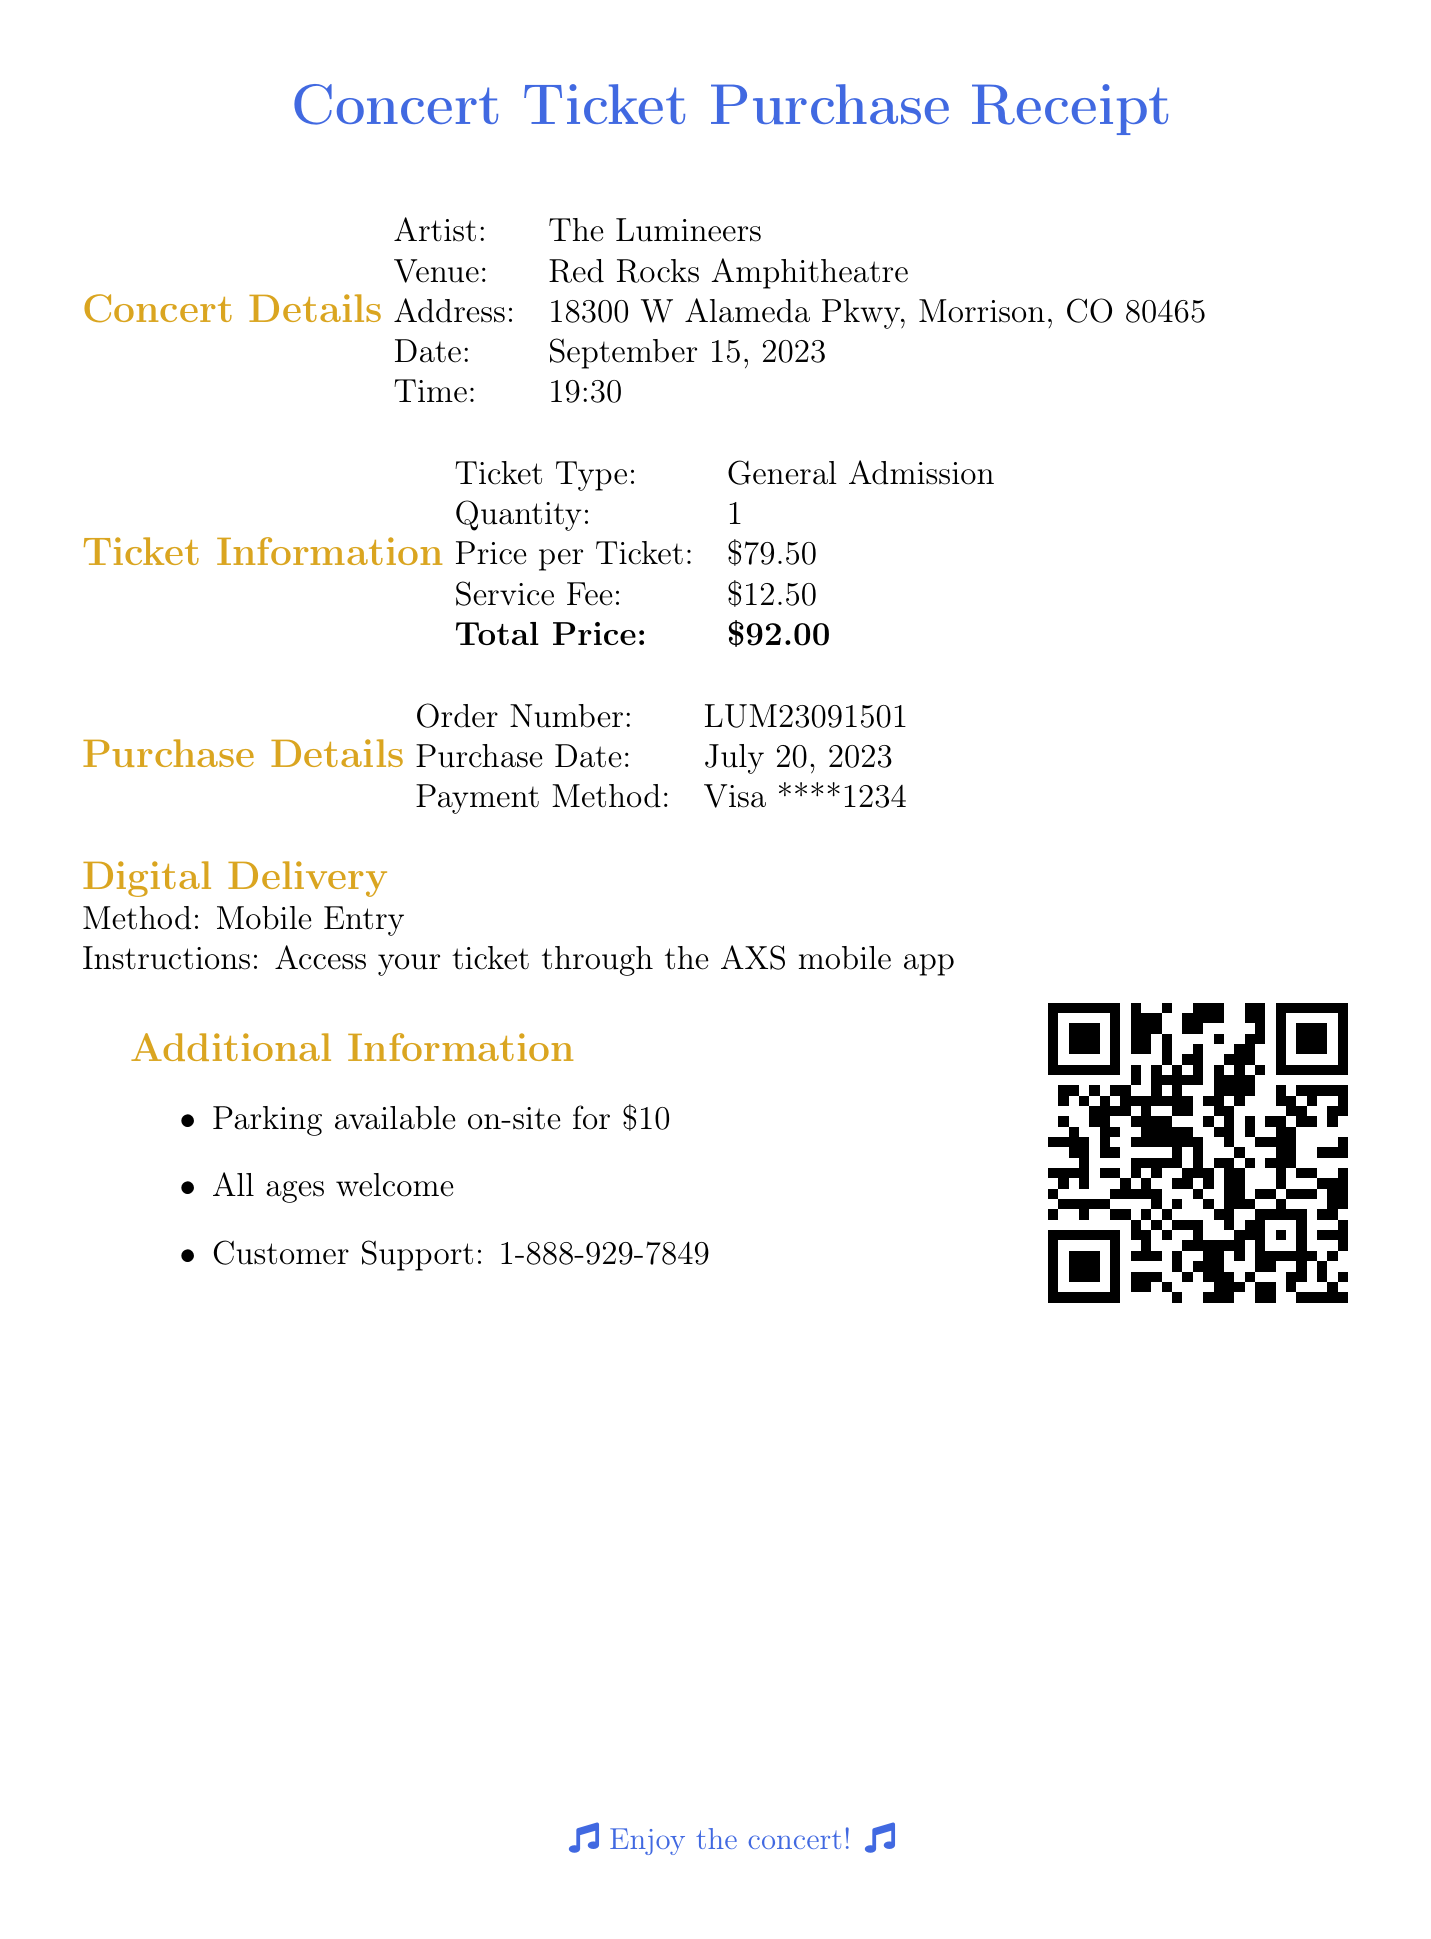What is the artist's name? The artist's name is explicitly stated in the concert details section of the document.
Answer: The Lumineers What is the venue for the concert? The venue is listed in the concert details section of the document.
Answer: Red Rocks Amphitheatre What date is the concert scheduled for? The concert date is provided in the concert details section.
Answer: September 15, 2023 What is the total price of the ticket? The total price is detailed in the ticket information section and includes all fees.
Answer: $92.00 What is the order number for this purchase? The order number is specified in the purchase details section and serves as a unique identifier.
Answer: LUM23091501 What payment method was used for this purchase? The payment method is found in the purchase details, indicating how the transaction was processed.
Answer: Visa ****1234 How much is the service fee for the ticket? The service fee is clearly stated in the ticket information section of the document.
Answer: $12.50 What delivery method will be used for the ticket? The digital delivery method is specified in the digital delivery section of the document.
Answer: Mobile Entry What instructions are provided for accessing the ticket? The ticket access instructions are mentioned in the digital delivery section.
Answer: Access your ticket through the AXS mobile app Is parking available at the venue? The additional information section mentions whether parking is available or not.
Answer: Yes, parking available on-site for $10 